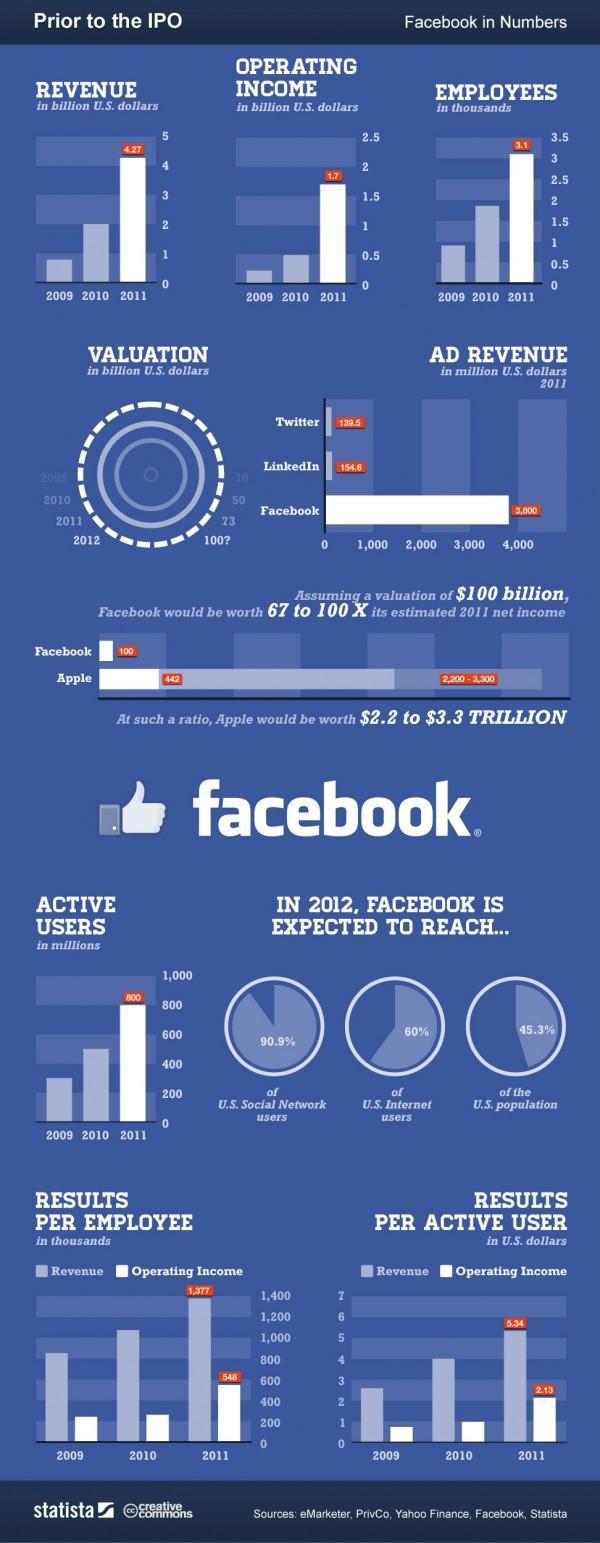In which year was the revenue highest?
Answer the question with a short phrase. 2011 Which social network contributed to the most Ad revenue in 2011? Facebook What was the operating income in 2011? 1.7 billion U.S. dollars What is the difference between revenue and operating income per active user in 2011? 3.21 U.S. dollars 